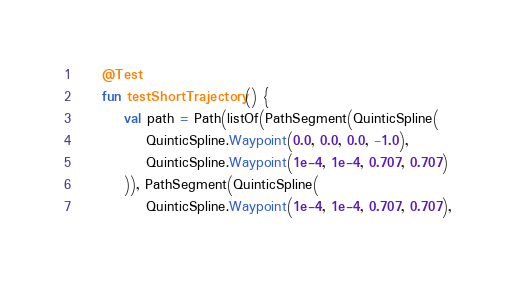Convert code to text. <code><loc_0><loc_0><loc_500><loc_500><_Kotlin_>
    @Test
    fun testShortTrajectory() {
        val path = Path(listOf(PathSegment(QuinticSpline(
            QuinticSpline.Waypoint(0.0, 0.0, 0.0, -1.0),
            QuinticSpline.Waypoint(1e-4, 1e-4, 0.707, 0.707)
        )), PathSegment(QuinticSpline(
            QuinticSpline.Waypoint(1e-4, 1e-4, 0.707, 0.707),</code> 